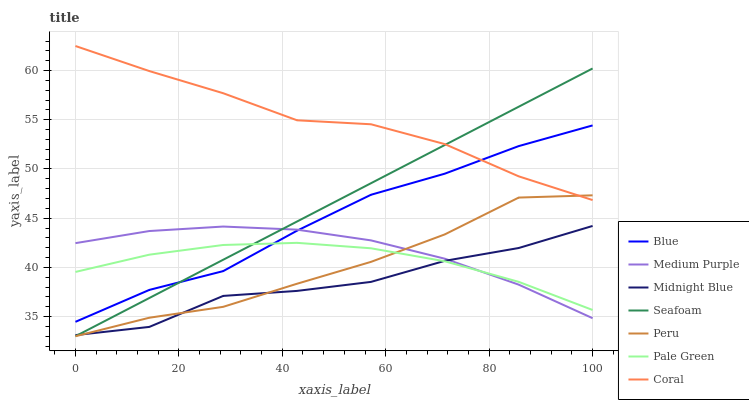Does Midnight Blue have the minimum area under the curve?
Answer yes or no. Yes. Does Coral have the maximum area under the curve?
Answer yes or no. Yes. Does Coral have the minimum area under the curve?
Answer yes or no. No. Does Midnight Blue have the maximum area under the curve?
Answer yes or no. No. Is Seafoam the smoothest?
Answer yes or no. Yes. Is Midnight Blue the roughest?
Answer yes or no. Yes. Is Coral the smoothest?
Answer yes or no. No. Is Coral the roughest?
Answer yes or no. No. Does Seafoam have the lowest value?
Answer yes or no. Yes. Does Midnight Blue have the lowest value?
Answer yes or no. No. Does Coral have the highest value?
Answer yes or no. Yes. Does Midnight Blue have the highest value?
Answer yes or no. No. Is Midnight Blue less than Coral?
Answer yes or no. Yes. Is Coral greater than Midnight Blue?
Answer yes or no. Yes. Does Blue intersect Pale Green?
Answer yes or no. Yes. Is Blue less than Pale Green?
Answer yes or no. No. Is Blue greater than Pale Green?
Answer yes or no. No. Does Midnight Blue intersect Coral?
Answer yes or no. No. 